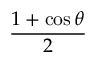<formula> <loc_0><loc_0><loc_500><loc_500>\frac { 1 + \cos \theta } { 2 }</formula> 